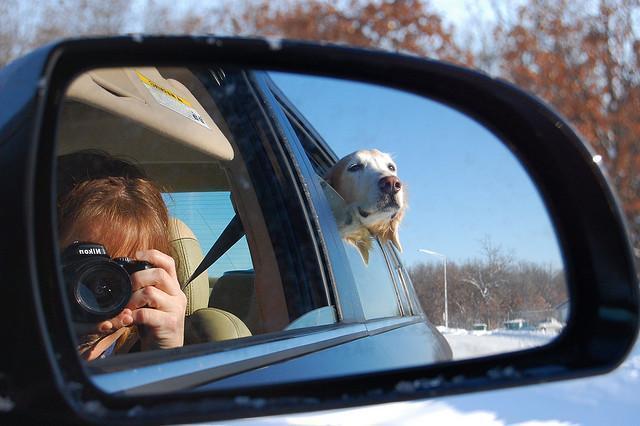Which lens used in side mirror of the car?
Answer the question by selecting the correct answer among the 4 following choices and explain your choice with a short sentence. The answer should be formatted with the following format: `Answer: choice
Rationale: rationale.`
Options: Macro, concave, convex, zoom. Answer: convex.
Rationale: B is actually a lens or mirror that curves inward. 